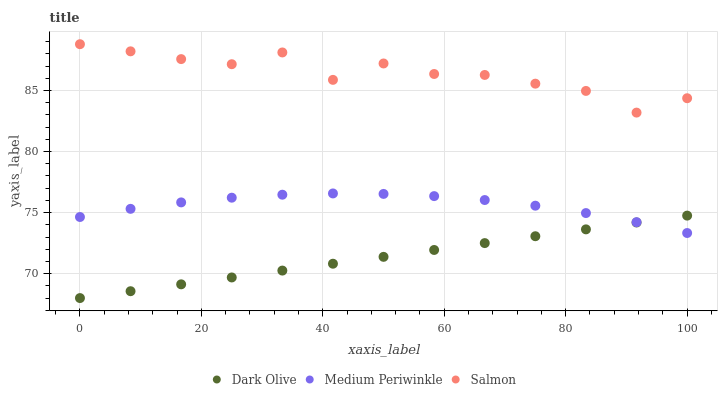Does Dark Olive have the minimum area under the curve?
Answer yes or no. Yes. Does Salmon have the maximum area under the curve?
Answer yes or no. Yes. Does Medium Periwinkle have the minimum area under the curve?
Answer yes or no. No. Does Medium Periwinkle have the maximum area under the curve?
Answer yes or no. No. Is Dark Olive the smoothest?
Answer yes or no. Yes. Is Salmon the roughest?
Answer yes or no. Yes. Is Medium Periwinkle the smoothest?
Answer yes or no. No. Is Medium Periwinkle the roughest?
Answer yes or no. No. Does Dark Olive have the lowest value?
Answer yes or no. Yes. Does Medium Periwinkle have the lowest value?
Answer yes or no. No. Does Salmon have the highest value?
Answer yes or no. Yes. Does Medium Periwinkle have the highest value?
Answer yes or no. No. Is Dark Olive less than Salmon?
Answer yes or no. Yes. Is Salmon greater than Medium Periwinkle?
Answer yes or no. Yes. Does Medium Periwinkle intersect Dark Olive?
Answer yes or no. Yes. Is Medium Periwinkle less than Dark Olive?
Answer yes or no. No. Is Medium Periwinkle greater than Dark Olive?
Answer yes or no. No. Does Dark Olive intersect Salmon?
Answer yes or no. No. 